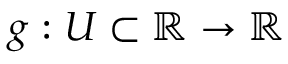Convert formula to latex. <formula><loc_0><loc_0><loc_500><loc_500>g \colon U \subset \mathbb { R } \to \mathbb { R }</formula> 